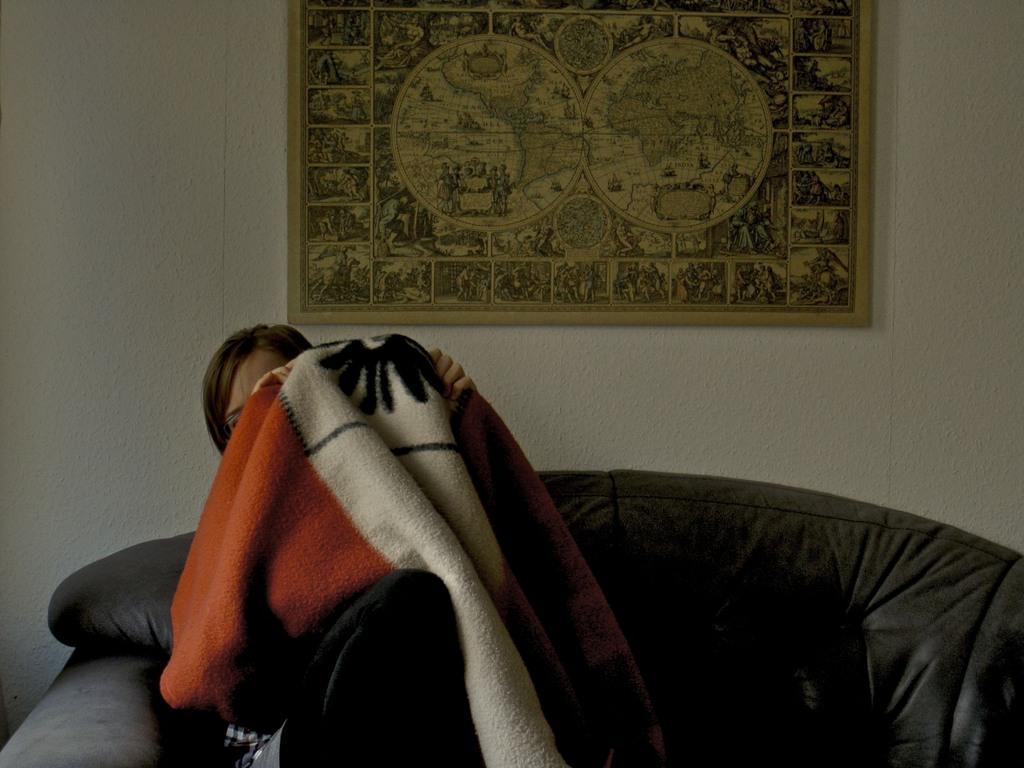Could you give a brief overview of what you see in this image? In the center of the image there is a woman holding a blanket sitting on a chair. In the background of the image there is a wall. There is a photo frame. 